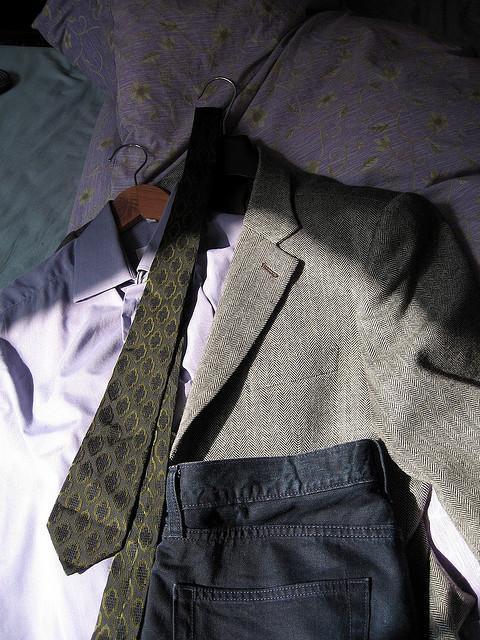How many ties can be seen?
Give a very brief answer. 1. 